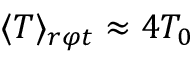<formula> <loc_0><loc_0><loc_500><loc_500>\langle T \rangle _ { r \varphi t } \approx 4 T _ { 0 }</formula> 